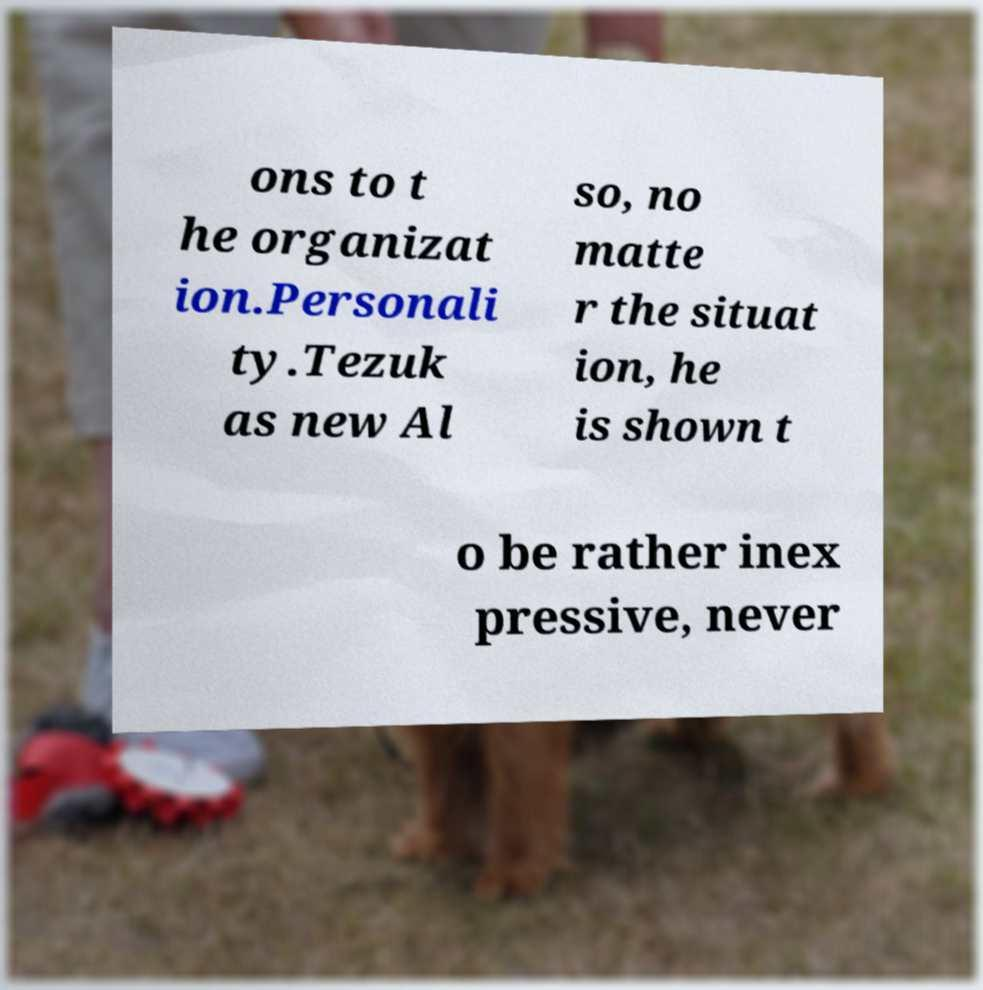For documentation purposes, I need the text within this image transcribed. Could you provide that? ons to t he organizat ion.Personali ty.Tezuk as new Al so, no matte r the situat ion, he is shown t o be rather inex pressive, never 